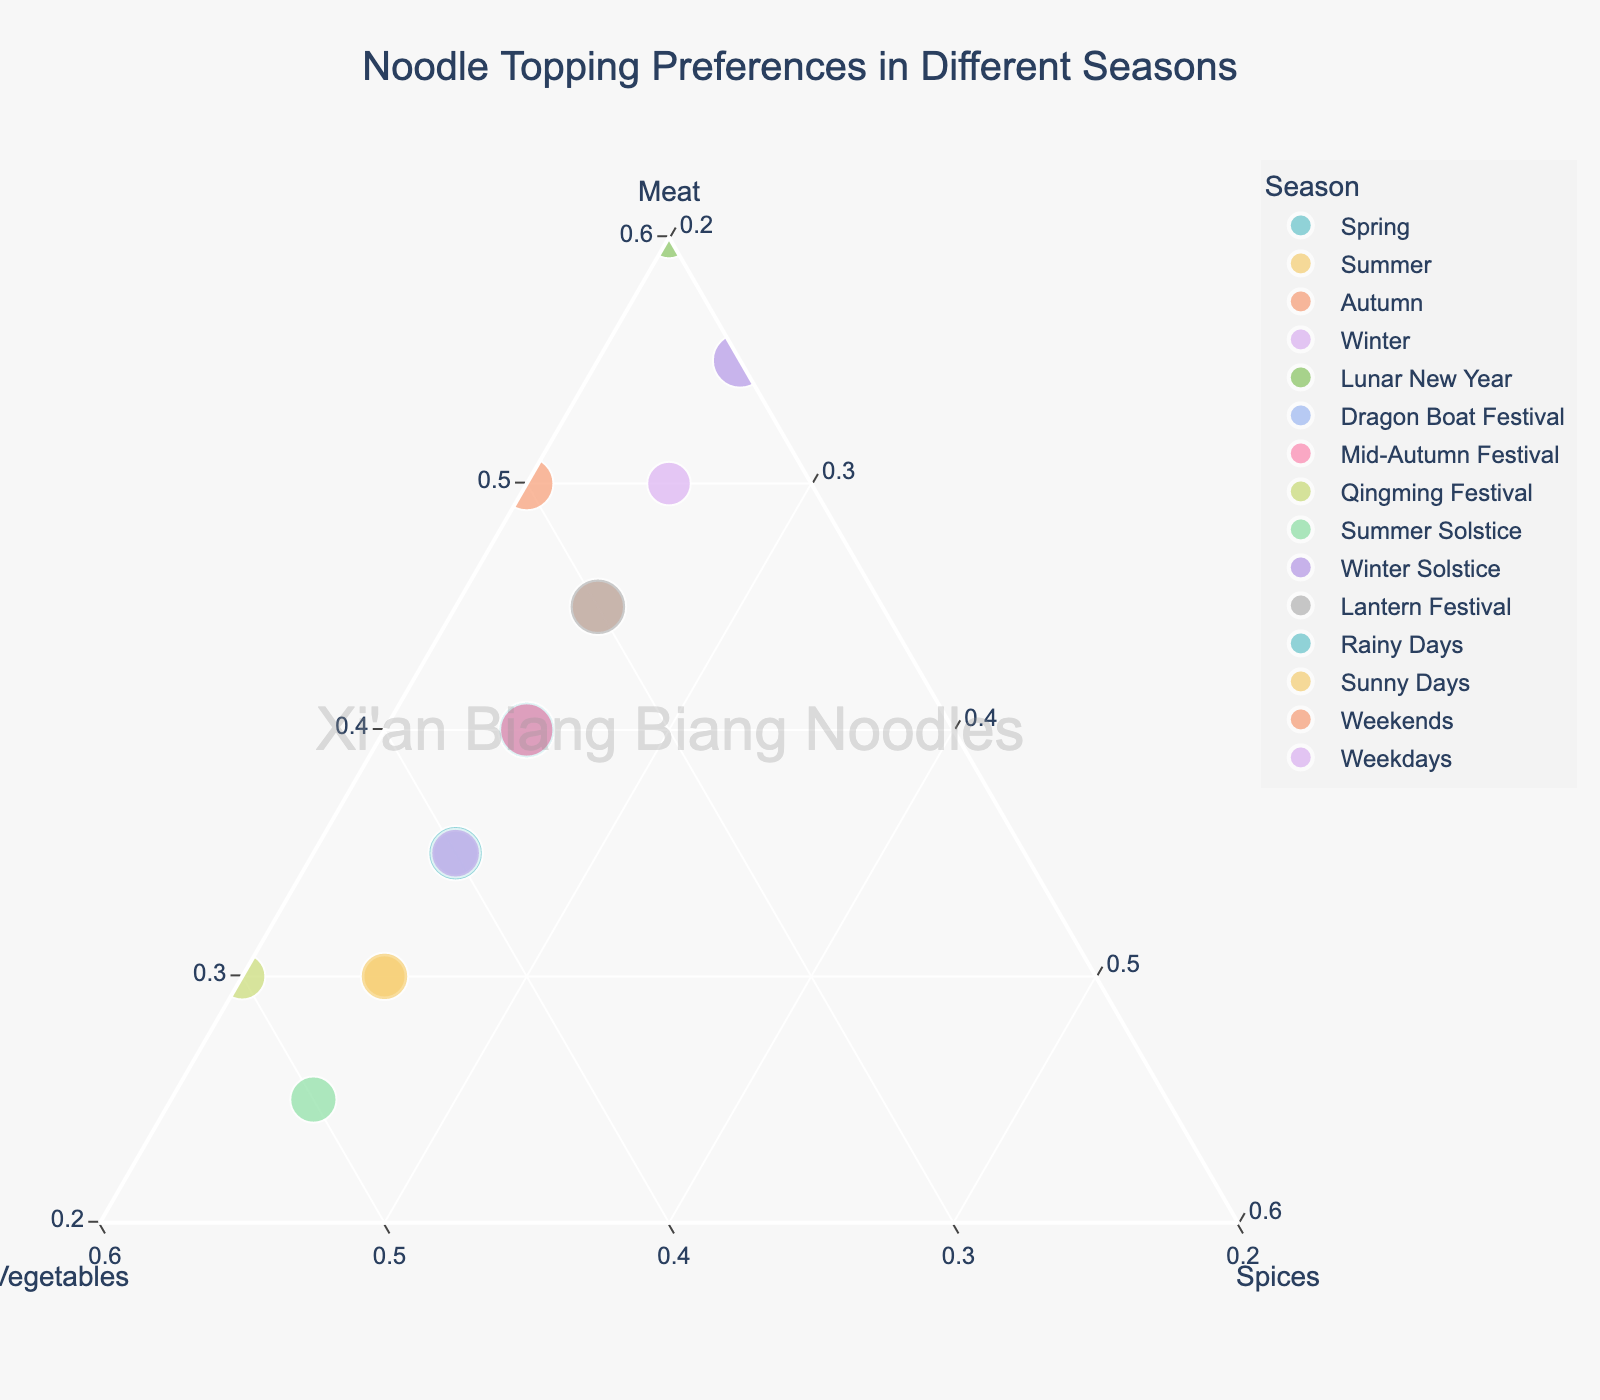What title is displayed on the ternary plot? The title is usually located at the top of the ternary plot. Observing the plot, the title reads "Noodle Topping Preferences in Different Seasons."
Answer: Noodle Topping Preferences in Different Seasons Which season shows the highest preference for vegetables and what is the percentage? To find this, look for the data point that is closest to the "Vegetables" axis. The plot shows "Qingming Festival" and "Summer Solstice" at the highest point, each with a vegetable preference percentage of 50%.
Answer: Qingming Festival, 50% What is the ratio of Meat to Vegetables in Winter Solstice? Look at the data point for "Winter Solstice" on the plot. The plot shows "Winter Solstice" with 55% Meat and 20% Vegetables. The ratio of Meat to Vegetables is 55:20, simplifying it to 11:4.
Answer: 11:4 Which seasons show exactly 25% preference for Spices? Spices percentage is represented on the "Spices" axis. Observing the plot, the seasons with 25% Spices are: Spring, Summer, Autumn, Winter, Dragon Boat Festival, Mid-Autumn Festival, Summer Solstice, and Lantern Festival.
Answer: Spring, Summer, Autumn, Winter, Dragon Boat Festival, Mid-Autumn Festival, Summer Solstice, Lantern Festival During which season is the preference for Meat at least 50%? To determine this, find data points where preference for Meat is at least 50%. "Winter" (50%), "Lunar New Year" (60%), "Winter Solstice" (55%), and "Weekends" (50%) meet this criterion.
Answer: Winter, Lunar New Year, Winter Solstice, Weekends 